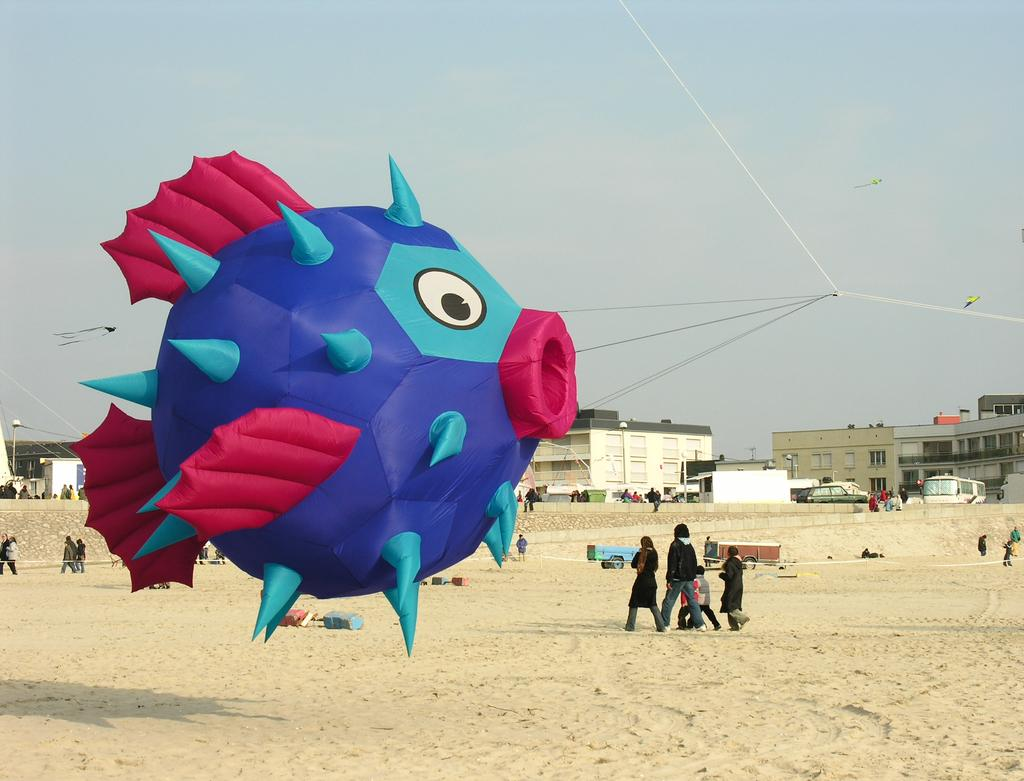What type of air balloon is in the image? There is a fish-shaped air balloon in the image. Who or what else is present in the image? There are people and cars in the image. What type of structures can be seen in the image? There are buildings in the image. How many legs does the fish-shaped air balloon have in the image? The fish-shaped air balloon is an inanimate object and does not have legs. 